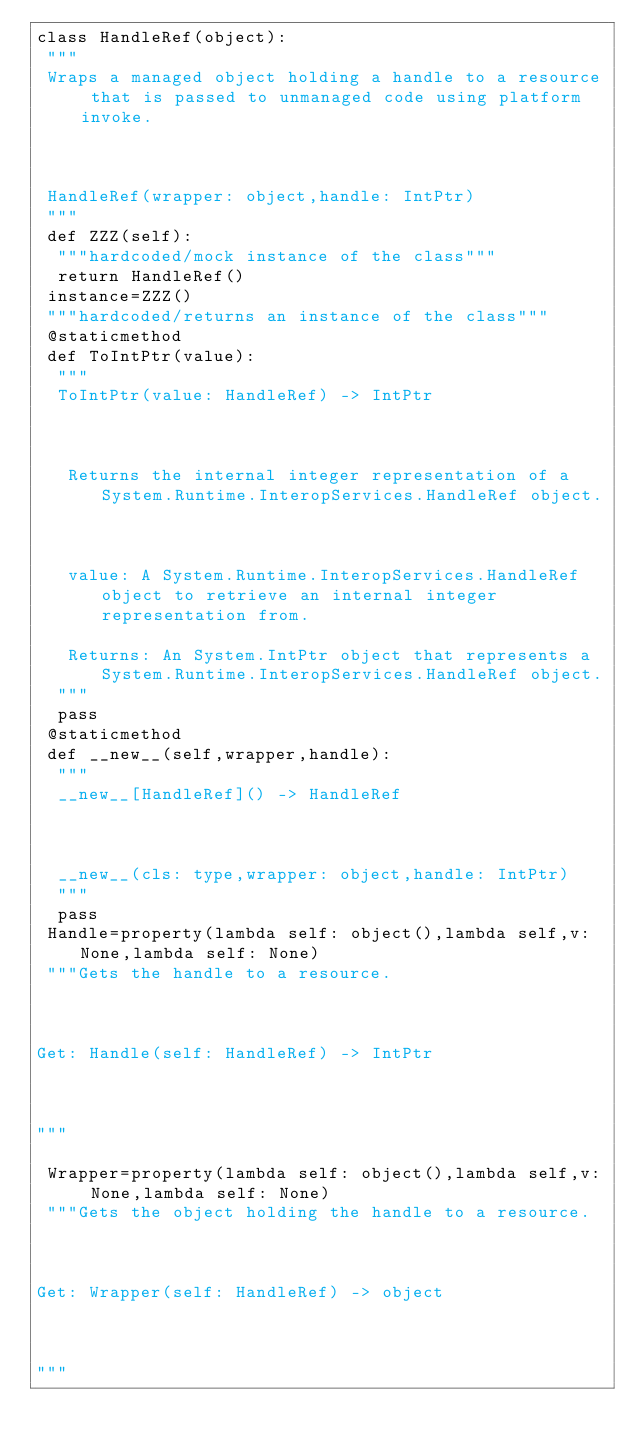Convert code to text. <code><loc_0><loc_0><loc_500><loc_500><_Python_>class HandleRef(object):
 """
 Wraps a managed object holding a handle to a resource that is passed to unmanaged code using platform invoke.
 
 HandleRef(wrapper: object,handle: IntPtr)
 """
 def ZZZ(self):
  """hardcoded/mock instance of the class"""
  return HandleRef()
 instance=ZZZ()
 """hardcoded/returns an instance of the class"""
 @staticmethod
 def ToIntPtr(value):
  """
  ToIntPtr(value: HandleRef) -> IntPtr
  
   Returns the internal integer representation of a System.Runtime.InteropServices.HandleRef object.
  
   value: A System.Runtime.InteropServices.HandleRef object to retrieve an internal integer representation from.
   Returns: An System.IntPtr object that represents a System.Runtime.InteropServices.HandleRef object.
  """
  pass
 @staticmethod
 def __new__(self,wrapper,handle):
  """
  __new__[HandleRef]() -> HandleRef
  
  __new__(cls: type,wrapper: object,handle: IntPtr)
  """
  pass
 Handle=property(lambda self: object(),lambda self,v: None,lambda self: None)
 """Gets the handle to a resource.

Get: Handle(self: HandleRef) -> IntPtr

"""

 Wrapper=property(lambda self: object(),lambda self,v: None,lambda self: None)
 """Gets the object holding the handle to a resource.

Get: Wrapper(self: HandleRef) -> object

"""


</code> 